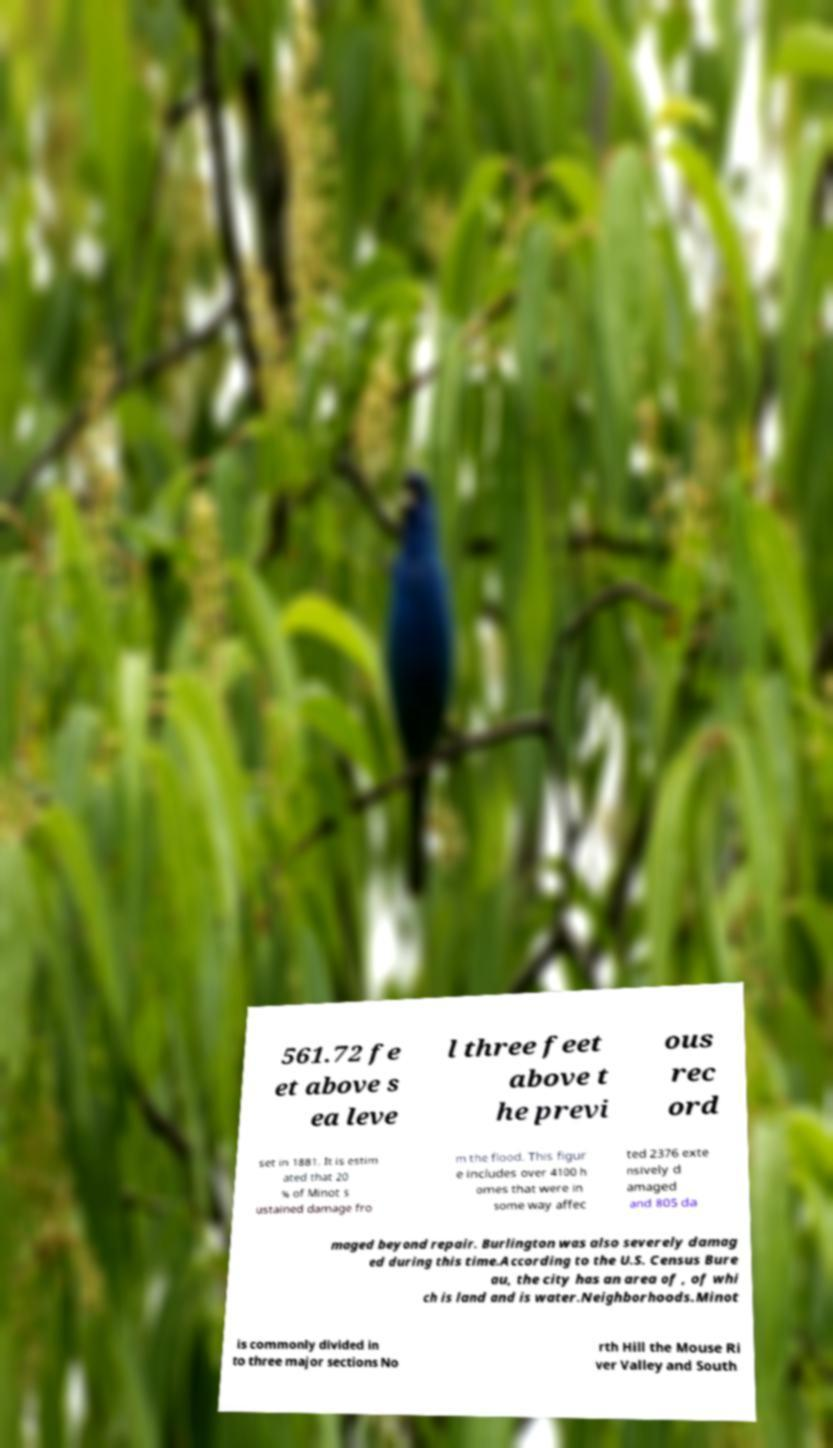Please read and relay the text visible in this image. What does it say? 561.72 fe et above s ea leve l three feet above t he previ ous rec ord set in 1881. It is estim ated that 20 % of Minot s ustained damage fro m the flood. This figur e includes over 4100 h omes that were in some way affec ted 2376 exte nsively d amaged and 805 da maged beyond repair. Burlington was also severely damag ed during this time.According to the U.S. Census Bure au, the city has an area of , of whi ch is land and is water.Neighborhoods.Minot is commonly divided in to three major sections No rth Hill the Mouse Ri ver Valley and South 